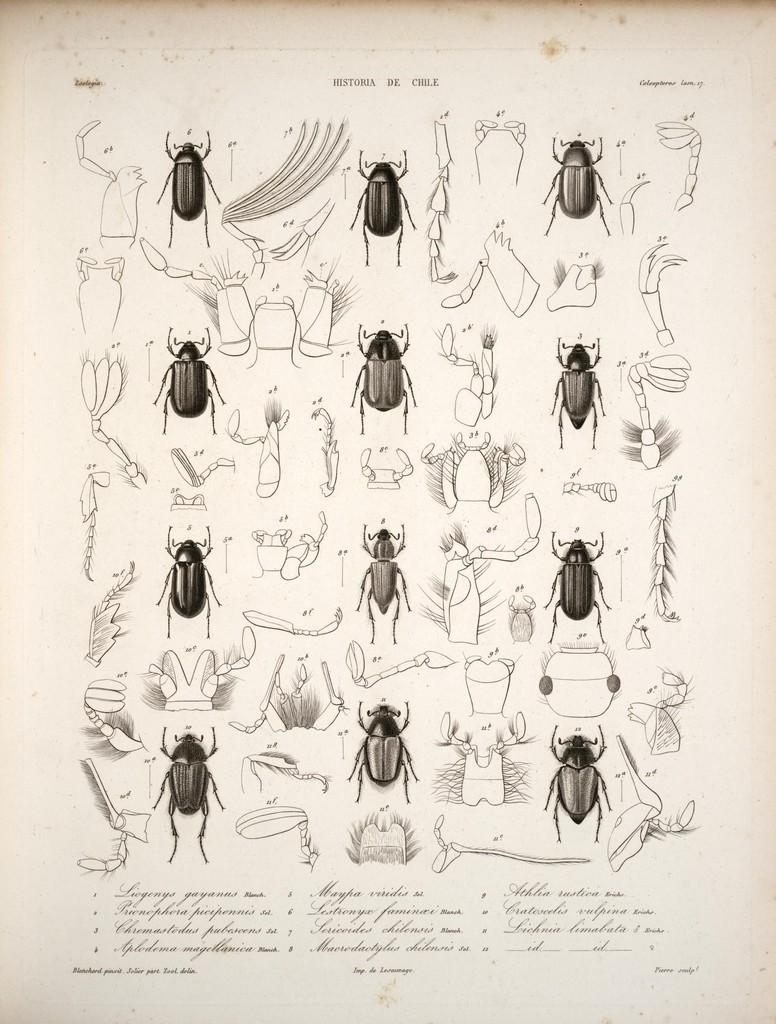What is the main subject of the image? The main subject of the image is pictures of insects. Where are the insect pictures located in the image? The insect pictures are in the middle of the image. What else can be seen at the bottom of the image? There is text written at the bottom of the image. What type of shade is being provided by the insects in the image? There is no shade provided by the insects in the image, as they are depicted in pictures and not in a real-life setting. 